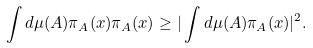<formula> <loc_0><loc_0><loc_500><loc_500>\int d \mu ( A ) \pi _ { A } ( x ) \pi _ { A } ( x ) \geq | \int d \mu ( A ) \pi _ { A } ( x ) | ^ { 2 } .</formula> 